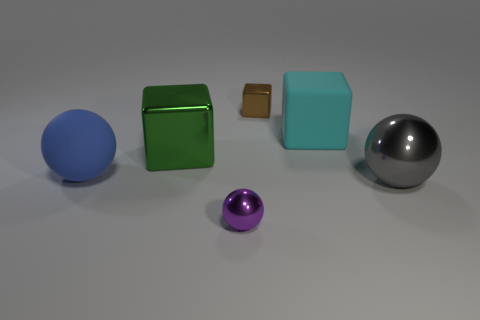Subtract all large spheres. How many spheres are left? 1 Add 4 metal blocks. How many objects exist? 10 Subtract 1 cubes. How many cubes are left? 2 Subtract all blue cubes. Subtract all brown cylinders. How many cubes are left? 3 Subtract all green metallic blocks. Subtract all small purple cylinders. How many objects are left? 5 Add 5 cyan things. How many cyan things are left? 6 Add 2 tiny green shiny cylinders. How many tiny green shiny cylinders exist? 2 Subtract 1 cyan blocks. How many objects are left? 5 